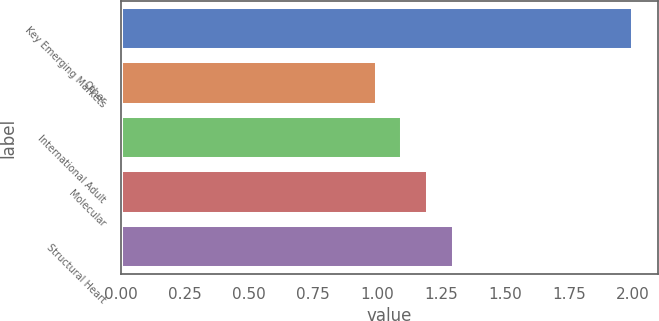Convert chart. <chart><loc_0><loc_0><loc_500><loc_500><bar_chart><fcel>Key Emerging Markets<fcel>Other<fcel>International Adult<fcel>Molecular<fcel>Structural Heart<nl><fcel>2<fcel>1<fcel>1.1<fcel>1.2<fcel>1.3<nl></chart> 